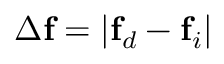<formula> <loc_0><loc_0><loc_500><loc_500>\Delta f = | f _ { d } - f _ { i } |</formula> 